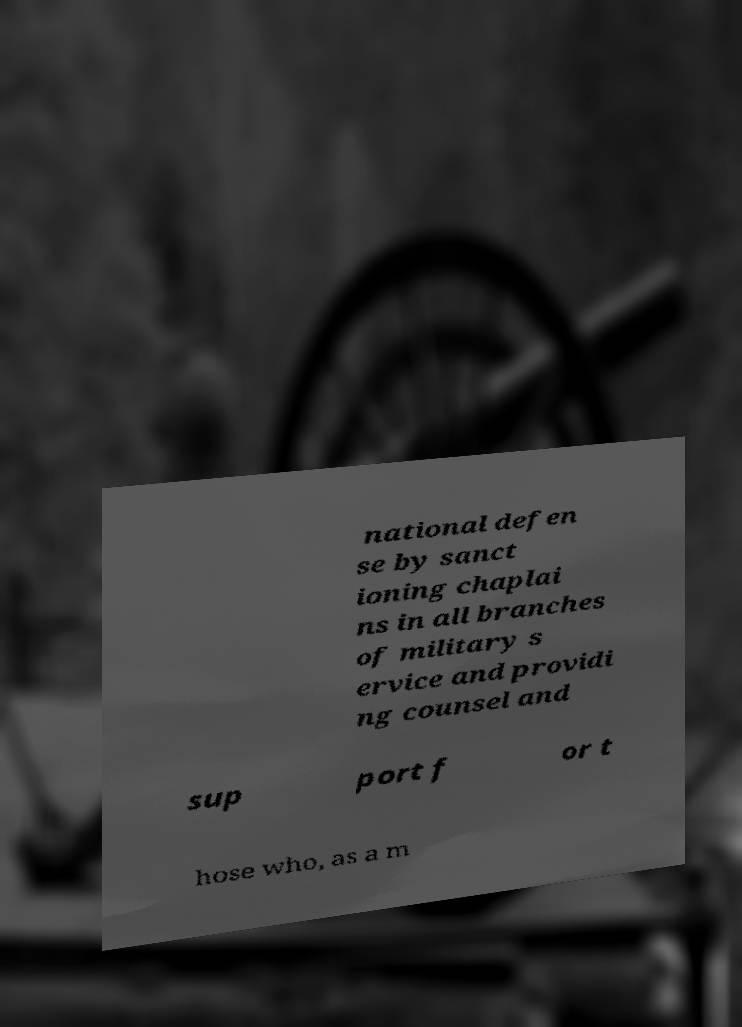Please read and relay the text visible in this image. What does it say? national defen se by sanct ioning chaplai ns in all branches of military s ervice and providi ng counsel and sup port f or t hose who, as a m 